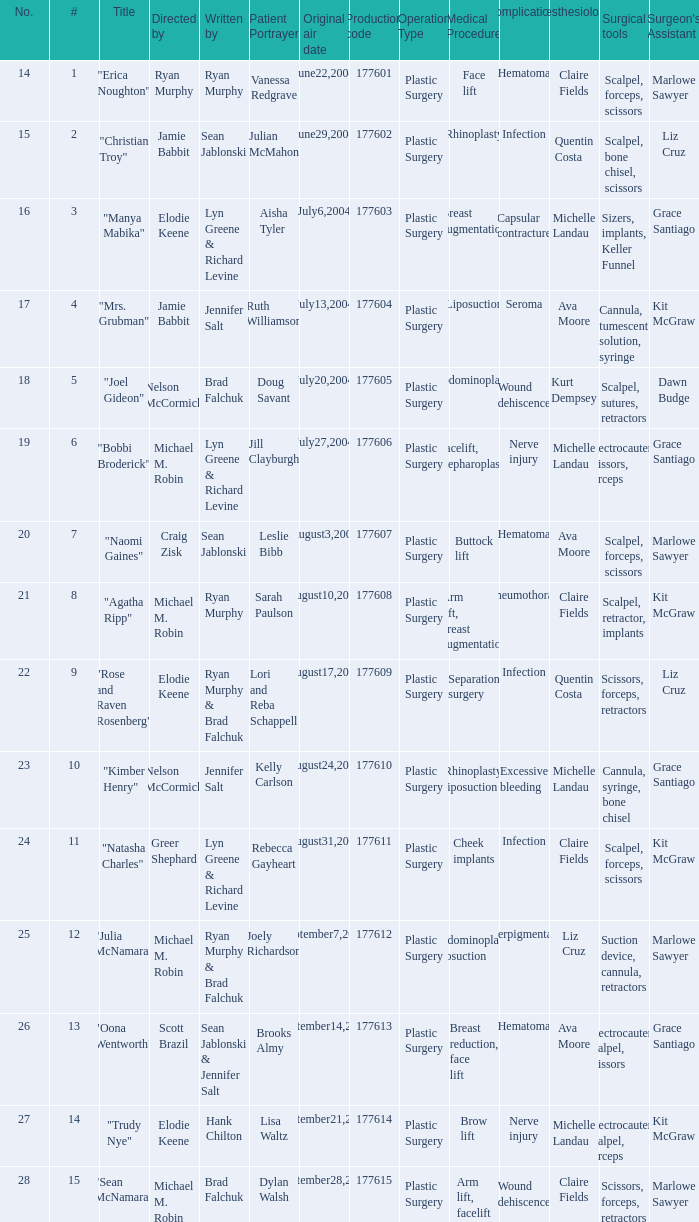How many episodes are numbered 4 in the season? 1.0. 